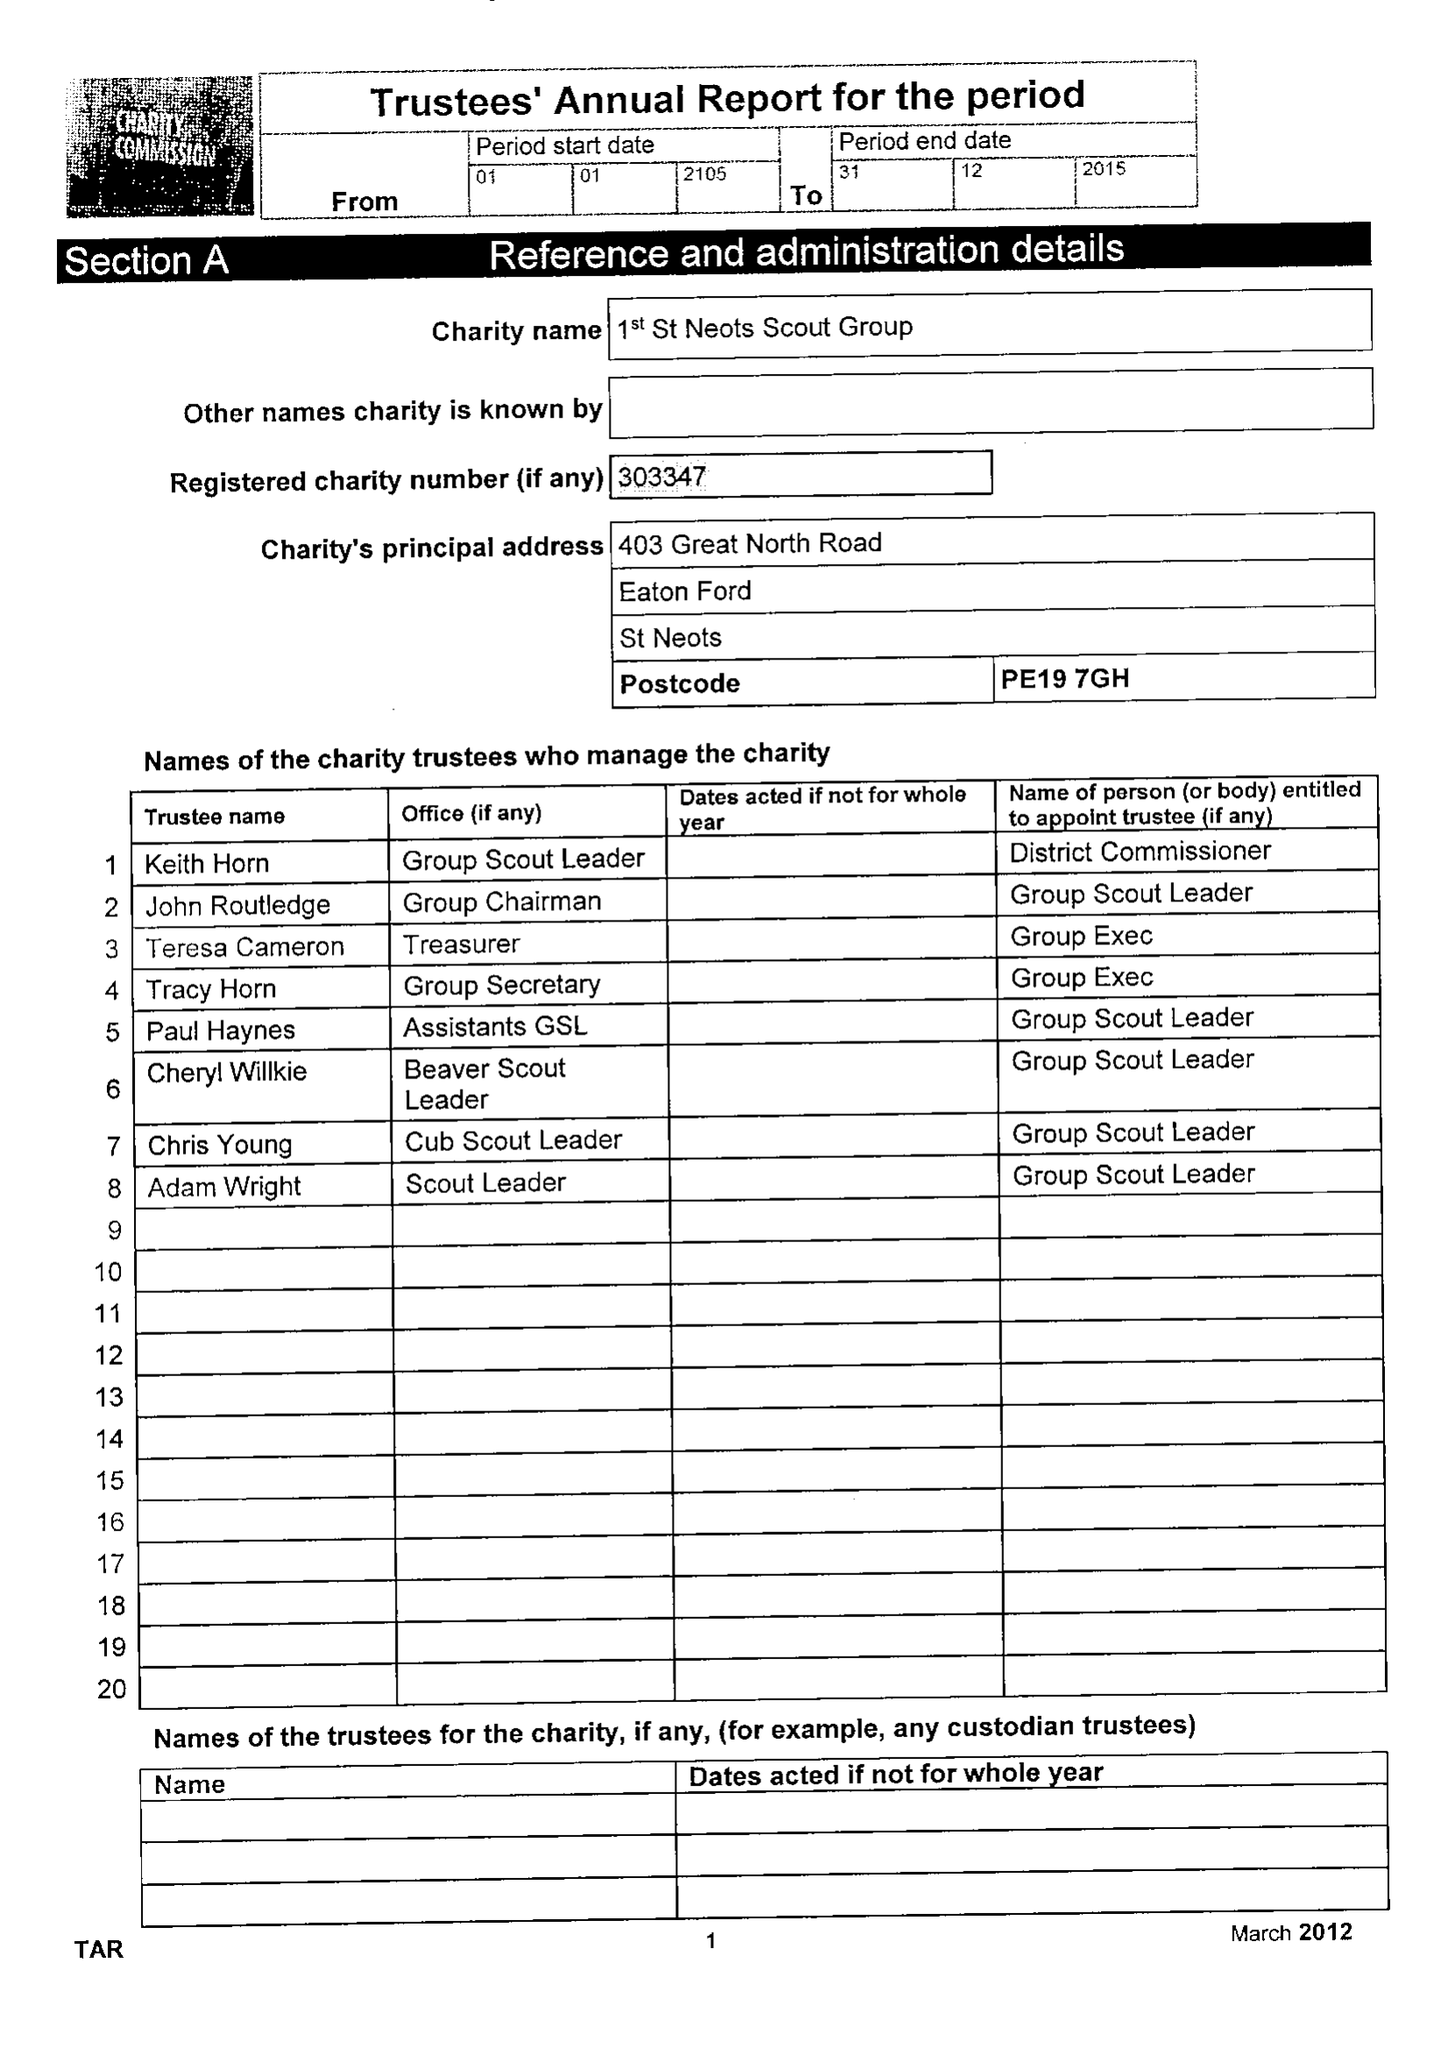What is the value for the address__street_line?
Answer the question using a single word or phrase. 403 GREAT NORTH ROAD 